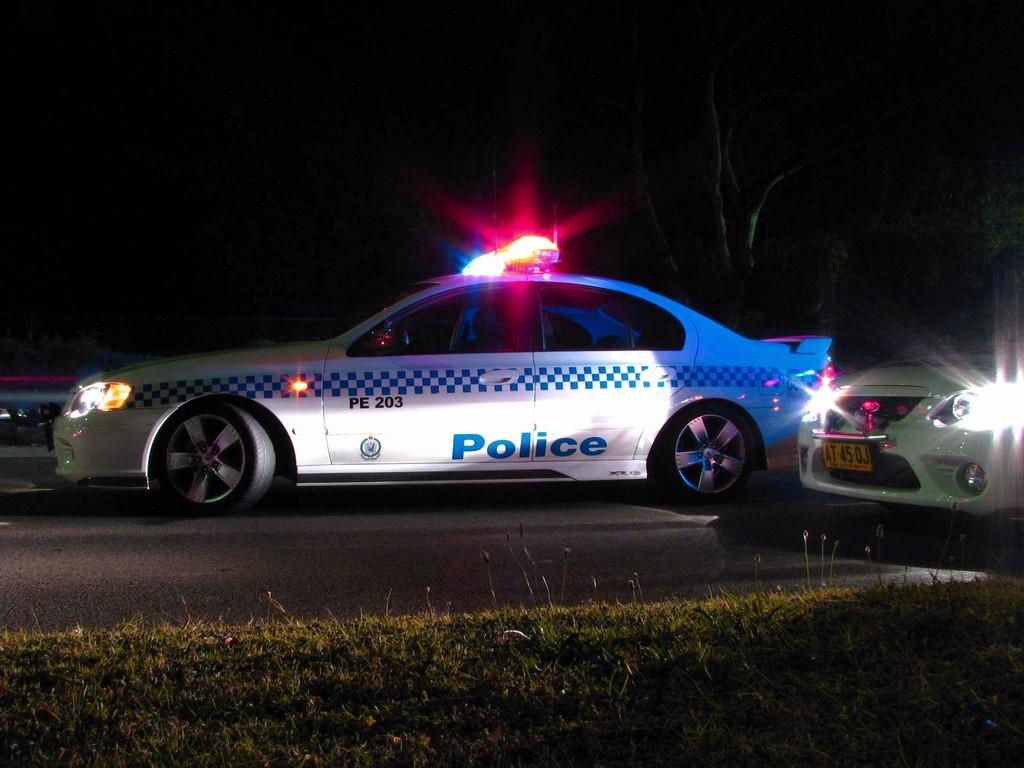Please provide a concise description of this image. In the center of the image we can see cars on the road. At the bottom of the image we can see grass. In the background there are trees. 